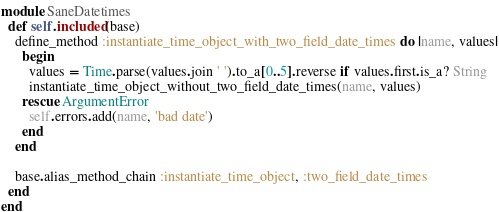Convert code to text. <code><loc_0><loc_0><loc_500><loc_500><_Ruby_>module SaneDatetimes
  def self.included(base)
    define_method :instantiate_time_object_with_two_field_date_times do |name, values|
      begin
        values = Time.parse(values.join ' ').to_a[0..5].reverse if values.first.is_a? String
        instantiate_time_object_without_two_field_date_times(name, values)
      rescue ArgumentError
        self.errors.add(name, 'bad date')
      end
    end

    base.alias_method_chain :instantiate_time_object, :two_field_date_times
  end
end

</code> 